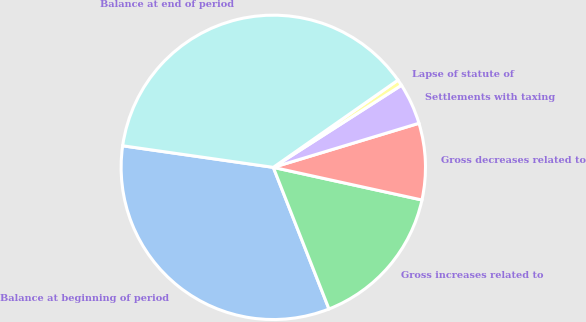Convert chart to OTSL. <chart><loc_0><loc_0><loc_500><loc_500><pie_chart><fcel>Balance at beginning of period<fcel>Gross increases related to<fcel>Gross decreases related to<fcel>Settlements with taxing<fcel>Lapse of statute of<fcel>Balance at end of period<nl><fcel>33.23%<fcel>15.6%<fcel>8.12%<fcel>4.39%<fcel>0.65%<fcel>38.02%<nl></chart> 